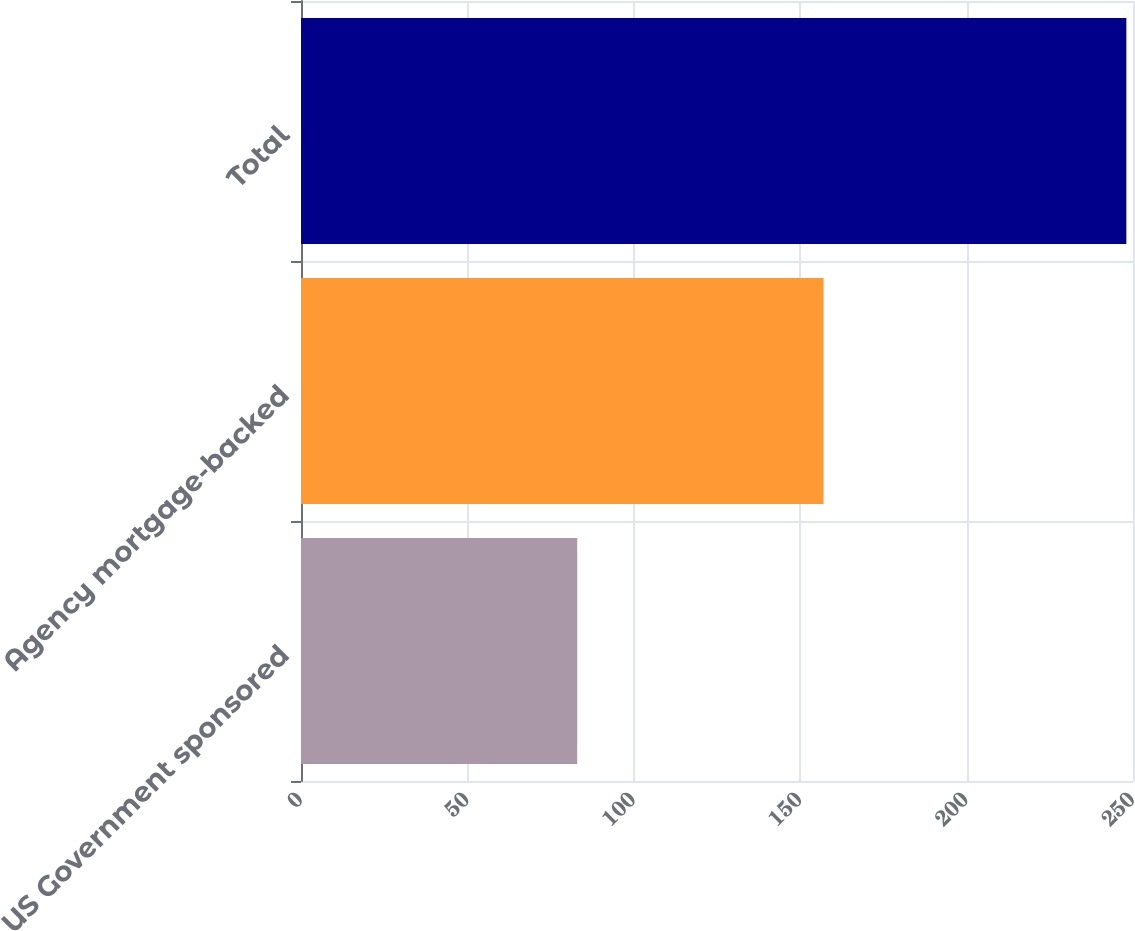<chart> <loc_0><loc_0><loc_500><loc_500><bar_chart><fcel>US Government sponsored<fcel>Agency mortgage-backed<fcel>Total<nl><fcel>83<fcel>157<fcel>248<nl></chart> 